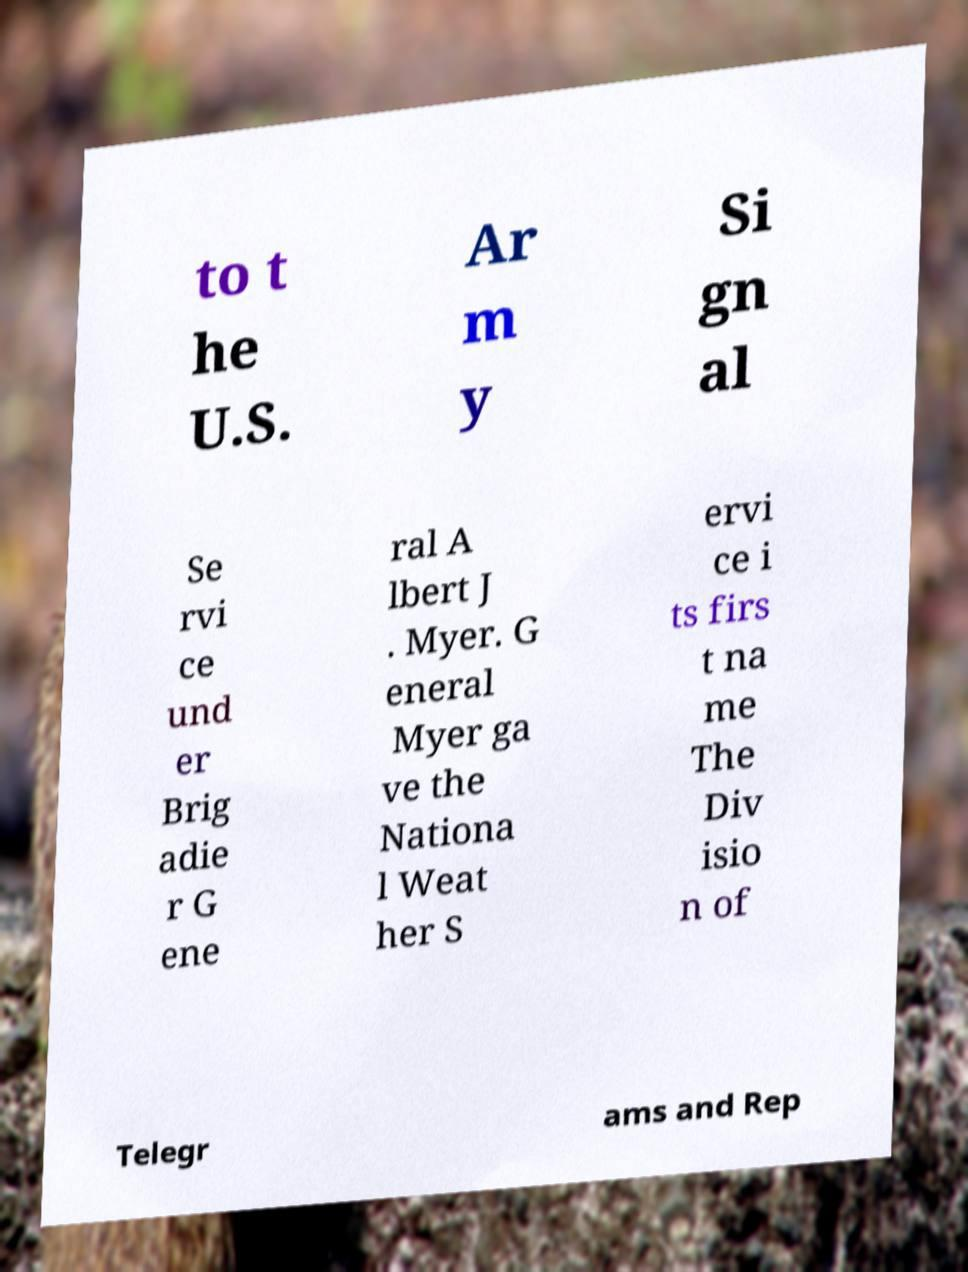Could you assist in decoding the text presented in this image and type it out clearly? to t he U.S. Ar m y Si gn al Se rvi ce und er Brig adie r G ene ral A lbert J . Myer. G eneral Myer ga ve the Nationa l Weat her S ervi ce i ts firs t na me The Div isio n of Telegr ams and Rep 